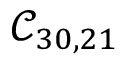Convert formula to latex. <formula><loc_0><loc_0><loc_500><loc_500>\mathcal { C } _ { 3 0 , 2 1 }</formula> 